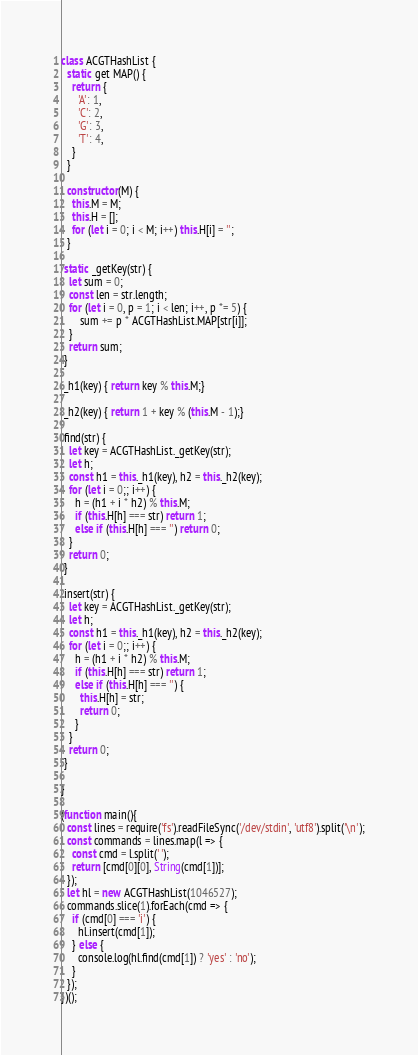Convert code to text. <code><loc_0><loc_0><loc_500><loc_500><_JavaScript_>class ACGTHashList {
  static get MAP() {
    return {
      'A': 1,
      'C': 2,
      'G': 3,
      'T': 4,
    }
  }

  constructor(M) {
    this.M = M;
    this.H = [];
    for (let i = 0; i < M; i++) this.H[i] = '';
  }

 static _getKey(str) {
   let sum = 0;
   const len = str.length;
   for (let i = 0, p = 1; i < len; i++, p *= 5) {
       sum += p * ACGTHashList.MAP[str[i]];
   }
   return sum;
 }

 _h1(key) { return key % this.M;}

 _h2(key) { return 1 + key % (this.M - 1);}

 find(str) {
   let key = ACGTHashList._getKey(str);
   let h;
   const h1 = this._h1(key), h2 = this._h2(key);
   for (let i = 0;; i++) {
     h = (h1 + i * h2) % this.M;
     if (this.H[h] === str) return 1;
     else if (this.H[h] === '') return 0;
   }
   return 0;
 }

 insert(str) {
   let key = ACGTHashList._getKey(str);
   let h;
   const h1 = this._h1(key), h2 = this._h2(key);
   for (let i = 0;; i++) {
     h = (h1 + i * h2) % this.M;
     if (this.H[h] === str) return 1;
     else if (this.H[h] === '') {
       this.H[h] = str;
       return 0;
     }
   }
   return 0;
 }

}

(function main(){
  const lines = require('fs').readFileSync('/dev/stdin', 'utf8').split('\n');
  const commands = lines.map(l => {
    const cmd = l.split(' ');
    return [cmd[0][0], String(cmd[1])];
  });
  let hl = new ACGTHashList(1046527);
  commands.slice(1).forEach(cmd => {
    if (cmd[0] === 'i') {
      hl.insert(cmd[1]);
    } else {
      console.log(hl.find(cmd[1]) ? 'yes' : 'no');
    }
  });
})();

</code> 